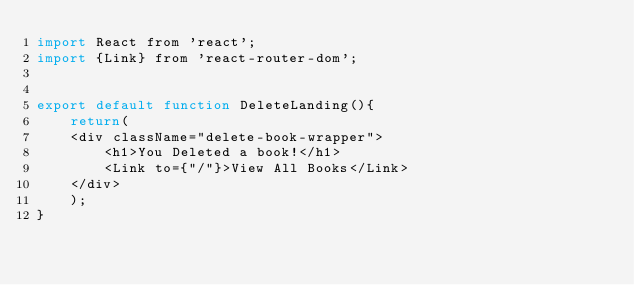<code> <loc_0><loc_0><loc_500><loc_500><_JavaScript_>import React from 'react';
import {Link} from 'react-router-dom';


export default function DeleteLanding(){
    return(
    <div className="delete-book-wrapper">
        <h1>You Deleted a book!</h1>
        <Link to={"/"}>View All Books</Link>
    </div>
    );
}</code> 